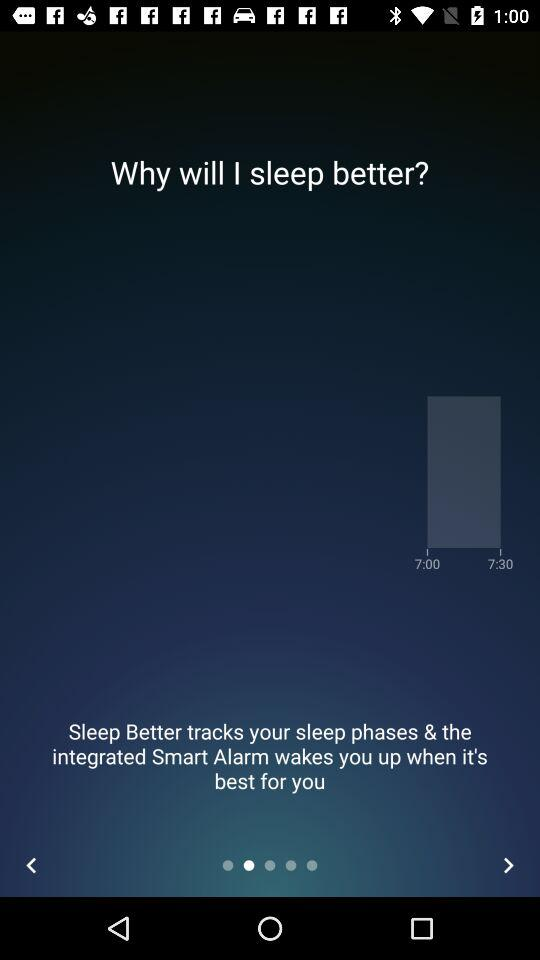How many alarm times are there?
Answer the question using a single word or phrase. 2 